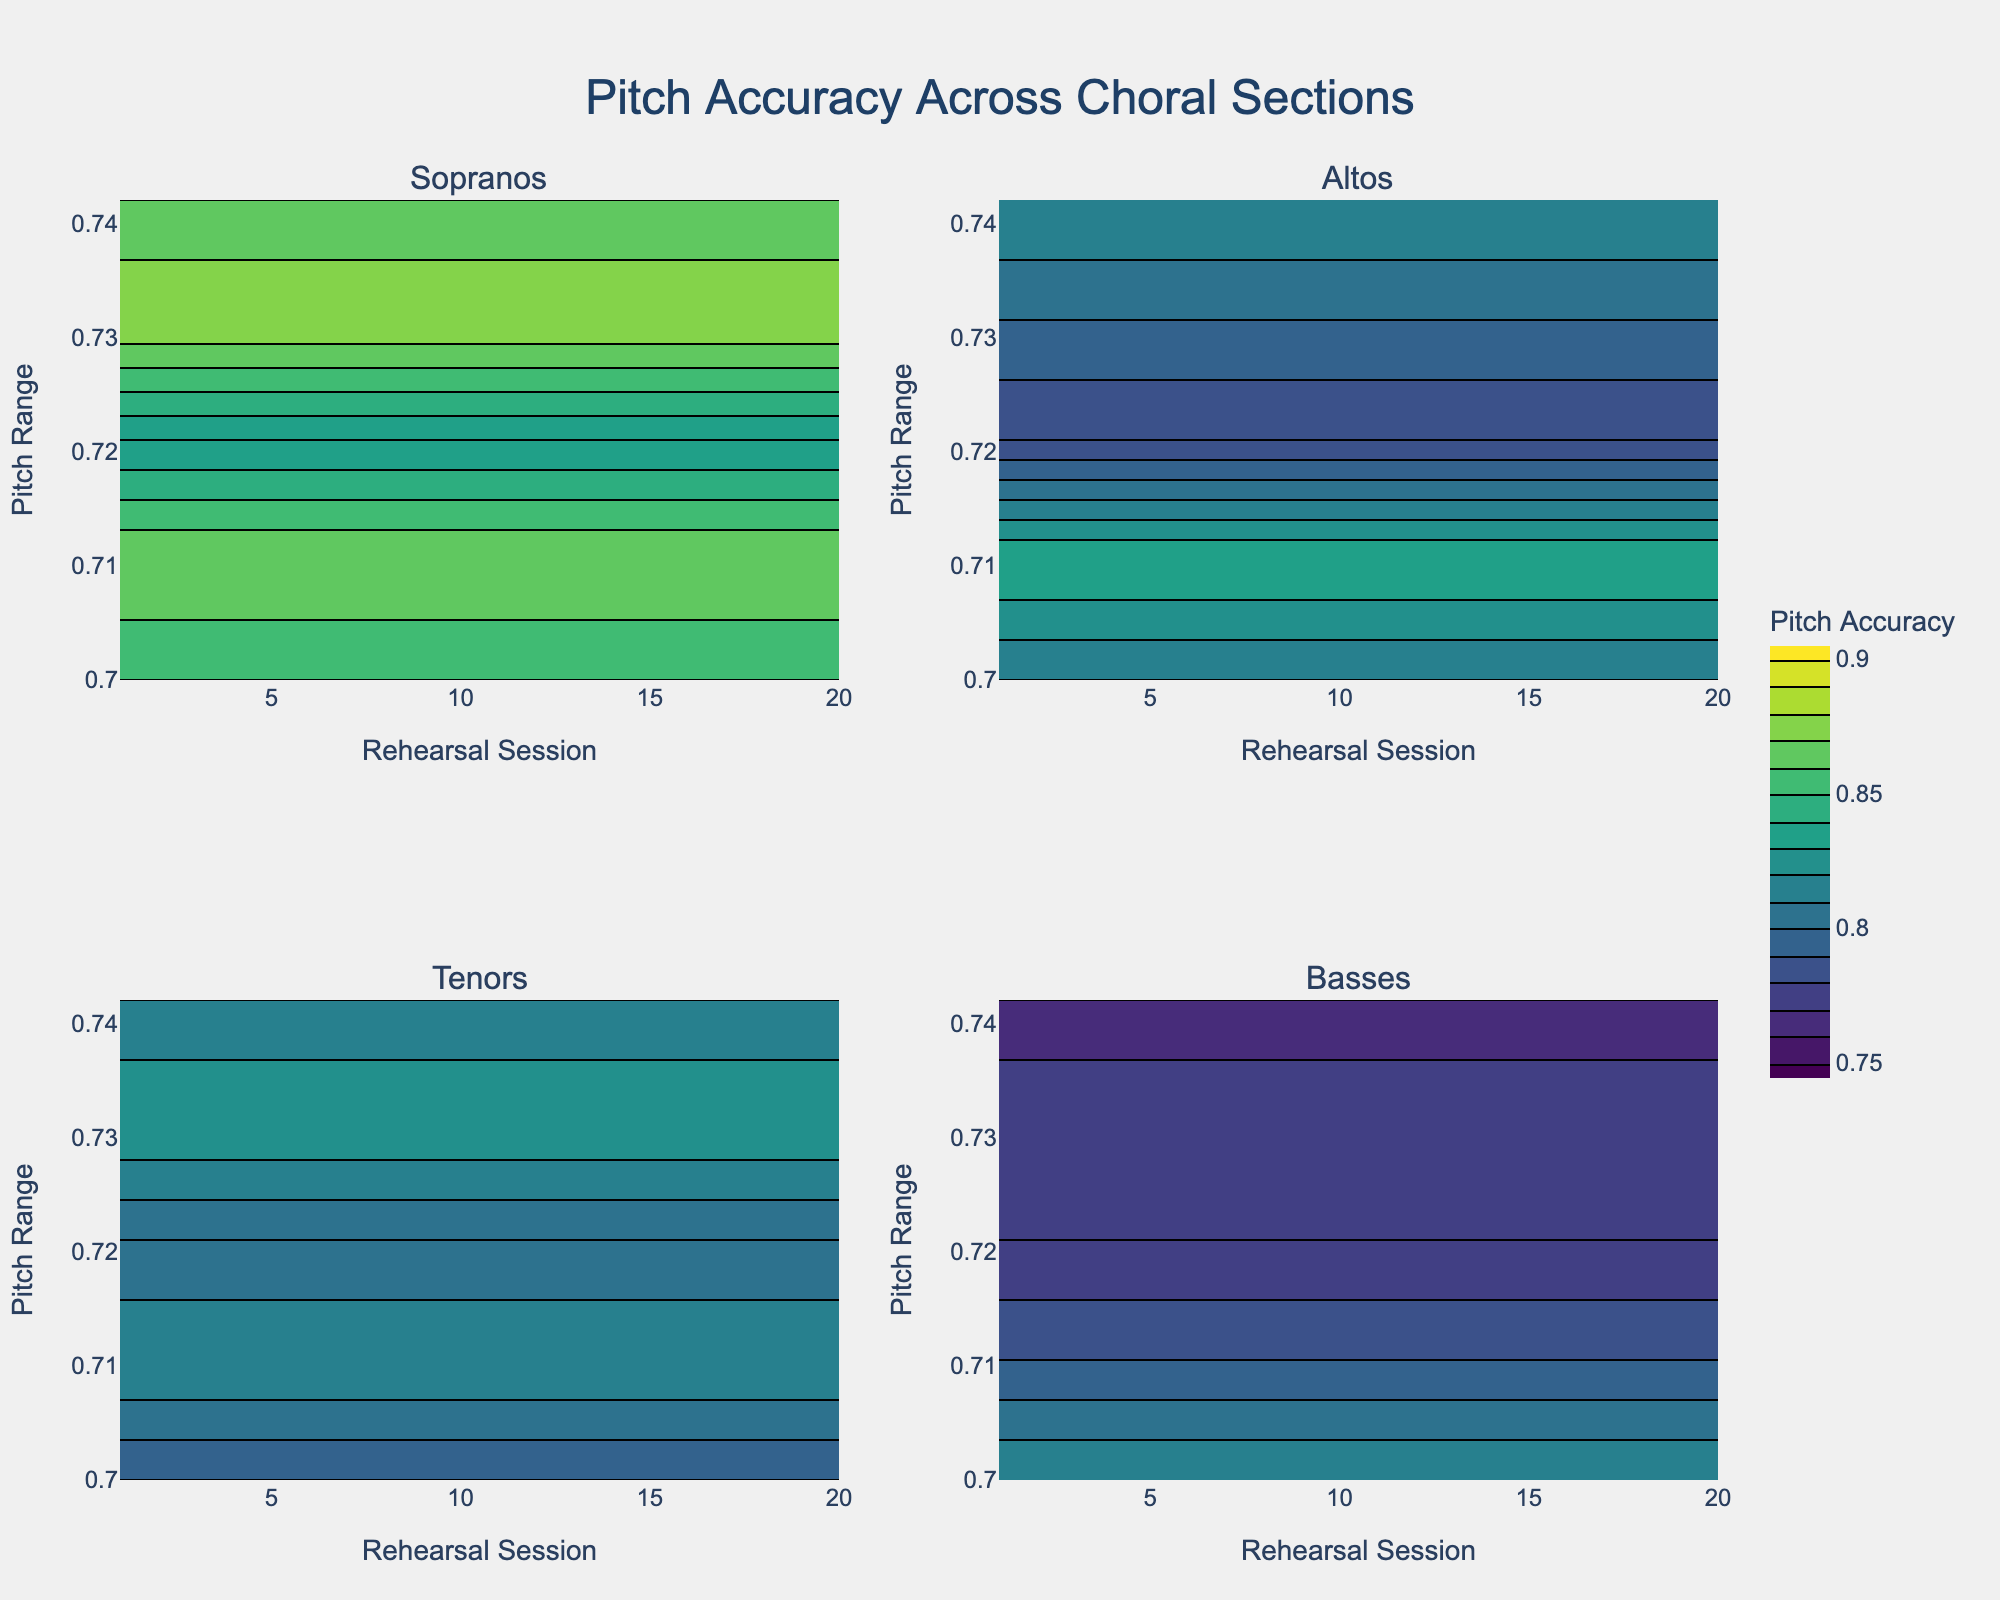How many sections are being compared in the subplot? The subplot has titles for each section. There are four titles: Sopranos, Altos, Tenors, and Basses.
Answer: Four sections Which choral section shows the highest pitch accuracy in the final rehearsal session? By looking at the Contour plots for each section, we observe the values corresponding to the 5th rehearsal session. Sopranos' plot shows the highest at session 5 with a pitch accuracy of about 0.86.
Answer: Sopranos Between the Tenors and Basses, which section has a more consistent pitch accuracy over the rehearsal sessions? Consistency can be inferred by looking at the spread and variation in the contour lines across sessions. Tenors have a tighter clustering indicating less variation, while Basses show more spread in contour lines.
Answer: Tenors What is the range of pitch accuracy covered in the plot for Altos? The color bar and contour lines for Altos show the minimum and maximum pitch accuracy. It ranges from around 0.75 to 0.84.
Answer: 0.75 to 0.84 On average, how does the pitch accuracy for Sopranos change over the rehearsal sessions? Considering the values 0.85, 0.87, 0.83, 0.88, 0.86, we sum them (4.29) and divide by the number of sessions (5).
Answer: 0.86 Which choral section shows the greatest improvement in pitch accuracy from session 1 to session 5? Improvement can be seen by looking at the difference in values from session 1 to session 5. Sopranos move from 0.85 to 0.86, Altos from 0.81 to 0.82, Tenors from 0.79 to 0.81, and Basses from 0.82 to 0.76.
Answer: Sopranos Comparing the color intensity, do the Tenors ever reach higher pitch accuracy than the Altos? By comparing the two contour plots, we notice that the Tenors' plot never reaches as high pitch accuracy values as the Altos.
Answer: No What pitch range is covered by the Sopranos during the 3rd rehearsal session? Referencing the contour plot at session 3 for Sopranos, the pitch values range from approximately 0.82 to 0.84.
Answer: 0.82 to 0.84 Which section has the most fluctuating pitch accuracy through the rehearsal sessions? Fluctuation can be assessed by the spread of the contour lines. The Basses' plot shows a larger spread in pitch accuracy than the other sections.
Answer: Basses What is the maximum pitch accuracy achieved by the Tenors over all rehearsal sessions? The highest value in the Tenors' contour plot is around 0.83 in the 4th session.
Answer: 0.83 